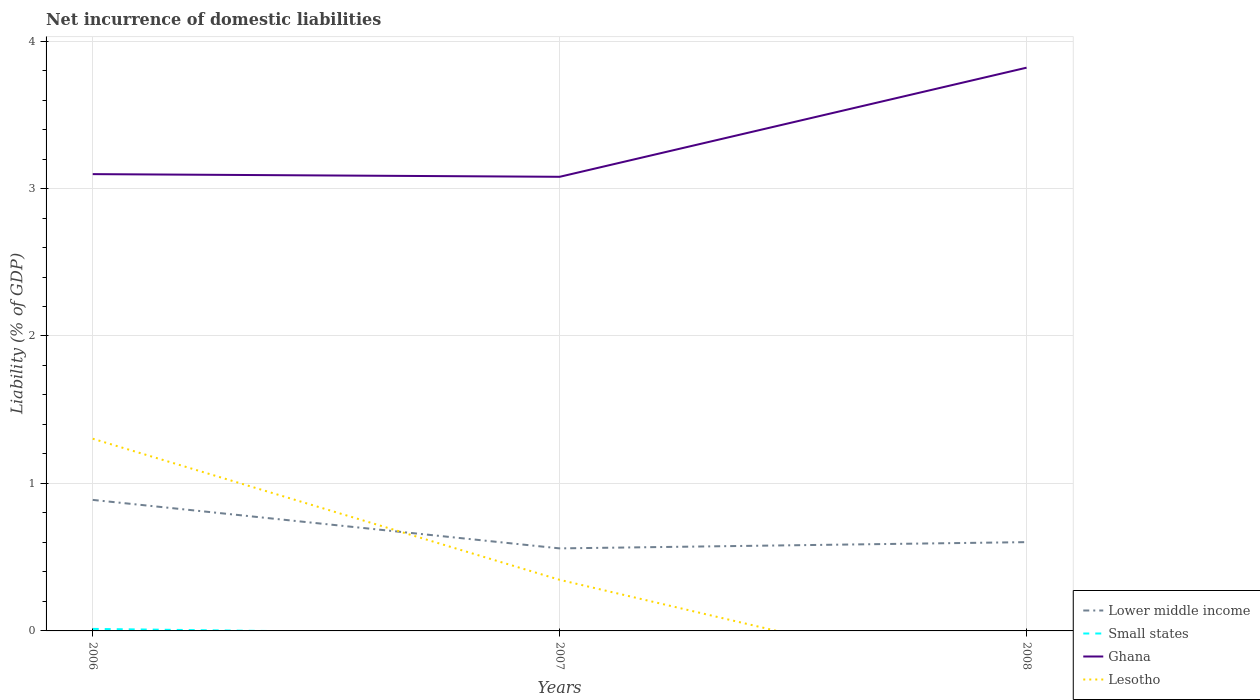How many different coloured lines are there?
Make the answer very short. 4. Is the number of lines equal to the number of legend labels?
Keep it short and to the point. No. Across all years, what is the maximum net incurrence of domestic liabilities in Lower middle income?
Your answer should be very brief. 0.56. What is the total net incurrence of domestic liabilities in Lower middle income in the graph?
Give a very brief answer. 0.33. What is the difference between the highest and the second highest net incurrence of domestic liabilities in Ghana?
Give a very brief answer. 0.74. What is the difference between the highest and the lowest net incurrence of domestic liabilities in Small states?
Offer a terse response. 1. Is the net incurrence of domestic liabilities in Lower middle income strictly greater than the net incurrence of domestic liabilities in Ghana over the years?
Your answer should be very brief. Yes. How many lines are there?
Make the answer very short. 4. How many years are there in the graph?
Your answer should be compact. 3. Does the graph contain any zero values?
Your answer should be very brief. Yes. Where does the legend appear in the graph?
Give a very brief answer. Bottom right. How many legend labels are there?
Give a very brief answer. 4. What is the title of the graph?
Offer a very short reply. Net incurrence of domestic liabilities. Does "Guinea-Bissau" appear as one of the legend labels in the graph?
Keep it short and to the point. No. What is the label or title of the X-axis?
Offer a terse response. Years. What is the label or title of the Y-axis?
Provide a succinct answer. Liability (% of GDP). What is the Liability (% of GDP) in Lower middle income in 2006?
Provide a short and direct response. 0.89. What is the Liability (% of GDP) in Small states in 2006?
Your answer should be very brief. 0.01. What is the Liability (% of GDP) of Ghana in 2006?
Your response must be concise. 3.1. What is the Liability (% of GDP) in Lesotho in 2006?
Make the answer very short. 1.3. What is the Liability (% of GDP) of Lower middle income in 2007?
Offer a very short reply. 0.56. What is the Liability (% of GDP) of Ghana in 2007?
Offer a very short reply. 3.08. What is the Liability (% of GDP) of Lesotho in 2007?
Give a very brief answer. 0.35. What is the Liability (% of GDP) of Lower middle income in 2008?
Provide a short and direct response. 0.6. What is the Liability (% of GDP) in Small states in 2008?
Ensure brevity in your answer.  0. What is the Liability (% of GDP) of Ghana in 2008?
Your answer should be very brief. 3.82. Across all years, what is the maximum Liability (% of GDP) of Lower middle income?
Offer a terse response. 0.89. Across all years, what is the maximum Liability (% of GDP) of Small states?
Keep it short and to the point. 0.01. Across all years, what is the maximum Liability (% of GDP) in Ghana?
Provide a succinct answer. 3.82. Across all years, what is the maximum Liability (% of GDP) in Lesotho?
Offer a terse response. 1.3. Across all years, what is the minimum Liability (% of GDP) of Lower middle income?
Your response must be concise. 0.56. Across all years, what is the minimum Liability (% of GDP) of Small states?
Keep it short and to the point. 0. Across all years, what is the minimum Liability (% of GDP) in Ghana?
Provide a short and direct response. 3.08. Across all years, what is the minimum Liability (% of GDP) in Lesotho?
Your answer should be compact. 0. What is the total Liability (% of GDP) of Lower middle income in the graph?
Provide a short and direct response. 2.05. What is the total Liability (% of GDP) in Small states in the graph?
Offer a terse response. 0.01. What is the total Liability (% of GDP) of Ghana in the graph?
Give a very brief answer. 10. What is the total Liability (% of GDP) in Lesotho in the graph?
Your answer should be compact. 1.65. What is the difference between the Liability (% of GDP) in Lower middle income in 2006 and that in 2007?
Ensure brevity in your answer.  0.33. What is the difference between the Liability (% of GDP) in Ghana in 2006 and that in 2007?
Ensure brevity in your answer.  0.02. What is the difference between the Liability (% of GDP) of Lesotho in 2006 and that in 2007?
Keep it short and to the point. 0.96. What is the difference between the Liability (% of GDP) in Lower middle income in 2006 and that in 2008?
Your answer should be very brief. 0.29. What is the difference between the Liability (% of GDP) of Ghana in 2006 and that in 2008?
Give a very brief answer. -0.72. What is the difference between the Liability (% of GDP) of Lower middle income in 2007 and that in 2008?
Your answer should be compact. -0.04. What is the difference between the Liability (% of GDP) in Ghana in 2007 and that in 2008?
Ensure brevity in your answer.  -0.74. What is the difference between the Liability (% of GDP) in Lower middle income in 2006 and the Liability (% of GDP) in Ghana in 2007?
Give a very brief answer. -2.19. What is the difference between the Liability (% of GDP) of Lower middle income in 2006 and the Liability (% of GDP) of Lesotho in 2007?
Keep it short and to the point. 0.54. What is the difference between the Liability (% of GDP) of Small states in 2006 and the Liability (% of GDP) of Ghana in 2007?
Your answer should be very brief. -3.07. What is the difference between the Liability (% of GDP) in Small states in 2006 and the Liability (% of GDP) in Lesotho in 2007?
Provide a short and direct response. -0.33. What is the difference between the Liability (% of GDP) in Ghana in 2006 and the Liability (% of GDP) in Lesotho in 2007?
Provide a succinct answer. 2.75. What is the difference between the Liability (% of GDP) of Lower middle income in 2006 and the Liability (% of GDP) of Ghana in 2008?
Ensure brevity in your answer.  -2.93. What is the difference between the Liability (% of GDP) in Small states in 2006 and the Liability (% of GDP) in Ghana in 2008?
Offer a very short reply. -3.81. What is the difference between the Liability (% of GDP) of Lower middle income in 2007 and the Liability (% of GDP) of Ghana in 2008?
Your answer should be very brief. -3.26. What is the average Liability (% of GDP) in Lower middle income per year?
Ensure brevity in your answer.  0.68. What is the average Liability (% of GDP) in Small states per year?
Your answer should be compact. 0. What is the average Liability (% of GDP) in Ghana per year?
Ensure brevity in your answer.  3.33. What is the average Liability (% of GDP) in Lesotho per year?
Make the answer very short. 0.55. In the year 2006, what is the difference between the Liability (% of GDP) of Lower middle income and Liability (% of GDP) of Small states?
Make the answer very short. 0.87. In the year 2006, what is the difference between the Liability (% of GDP) in Lower middle income and Liability (% of GDP) in Ghana?
Offer a very short reply. -2.21. In the year 2006, what is the difference between the Liability (% of GDP) in Lower middle income and Liability (% of GDP) in Lesotho?
Offer a terse response. -0.41. In the year 2006, what is the difference between the Liability (% of GDP) in Small states and Liability (% of GDP) in Ghana?
Make the answer very short. -3.08. In the year 2006, what is the difference between the Liability (% of GDP) of Small states and Liability (% of GDP) of Lesotho?
Your response must be concise. -1.29. In the year 2006, what is the difference between the Liability (% of GDP) of Ghana and Liability (% of GDP) of Lesotho?
Your answer should be very brief. 1.79. In the year 2007, what is the difference between the Liability (% of GDP) in Lower middle income and Liability (% of GDP) in Ghana?
Your answer should be very brief. -2.52. In the year 2007, what is the difference between the Liability (% of GDP) in Lower middle income and Liability (% of GDP) in Lesotho?
Make the answer very short. 0.21. In the year 2007, what is the difference between the Liability (% of GDP) in Ghana and Liability (% of GDP) in Lesotho?
Your answer should be compact. 2.73. In the year 2008, what is the difference between the Liability (% of GDP) in Lower middle income and Liability (% of GDP) in Ghana?
Provide a succinct answer. -3.22. What is the ratio of the Liability (% of GDP) in Lower middle income in 2006 to that in 2007?
Provide a short and direct response. 1.59. What is the ratio of the Liability (% of GDP) in Ghana in 2006 to that in 2007?
Provide a succinct answer. 1.01. What is the ratio of the Liability (% of GDP) in Lesotho in 2006 to that in 2007?
Make the answer very short. 3.76. What is the ratio of the Liability (% of GDP) of Lower middle income in 2006 to that in 2008?
Your response must be concise. 1.48. What is the ratio of the Liability (% of GDP) of Ghana in 2006 to that in 2008?
Offer a very short reply. 0.81. What is the ratio of the Liability (% of GDP) of Lower middle income in 2007 to that in 2008?
Provide a short and direct response. 0.93. What is the ratio of the Liability (% of GDP) of Ghana in 2007 to that in 2008?
Provide a succinct answer. 0.81. What is the difference between the highest and the second highest Liability (% of GDP) of Lower middle income?
Make the answer very short. 0.29. What is the difference between the highest and the second highest Liability (% of GDP) of Ghana?
Make the answer very short. 0.72. What is the difference between the highest and the lowest Liability (% of GDP) of Lower middle income?
Keep it short and to the point. 0.33. What is the difference between the highest and the lowest Liability (% of GDP) of Small states?
Provide a short and direct response. 0.01. What is the difference between the highest and the lowest Liability (% of GDP) of Ghana?
Make the answer very short. 0.74. What is the difference between the highest and the lowest Liability (% of GDP) of Lesotho?
Give a very brief answer. 1.3. 